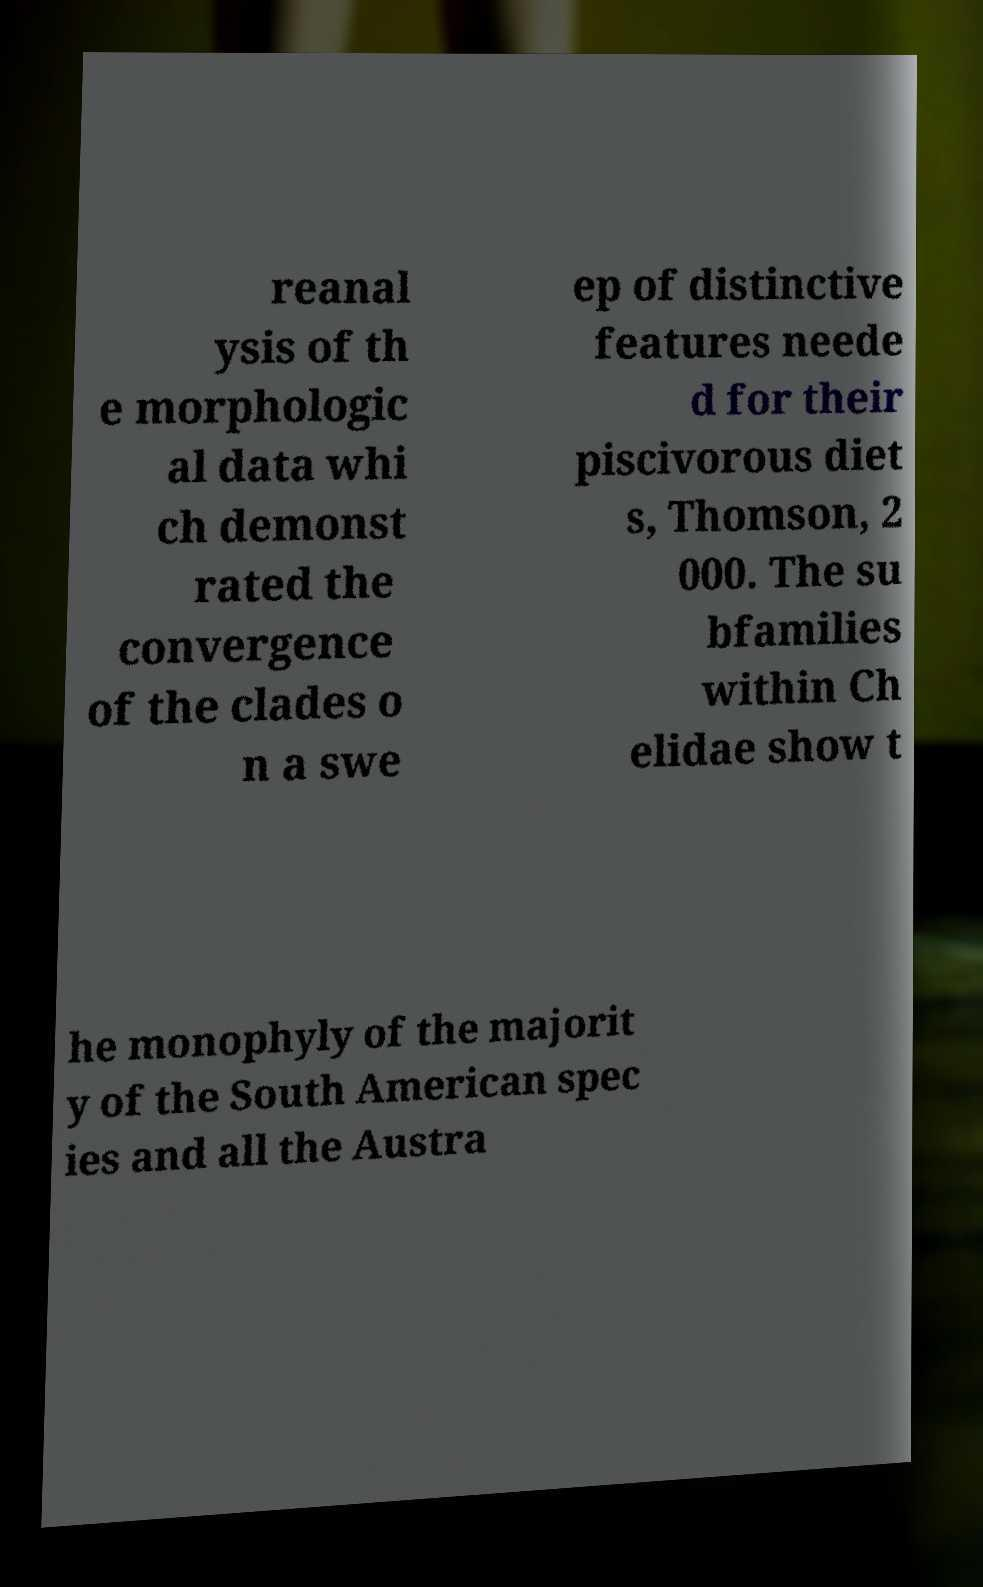Please identify and transcribe the text found in this image. reanal ysis of th e morphologic al data whi ch demonst rated the convergence of the clades o n a swe ep of distinctive features neede d for their piscivorous diet s, Thomson, 2 000. The su bfamilies within Ch elidae show t he monophyly of the majorit y of the South American spec ies and all the Austra 